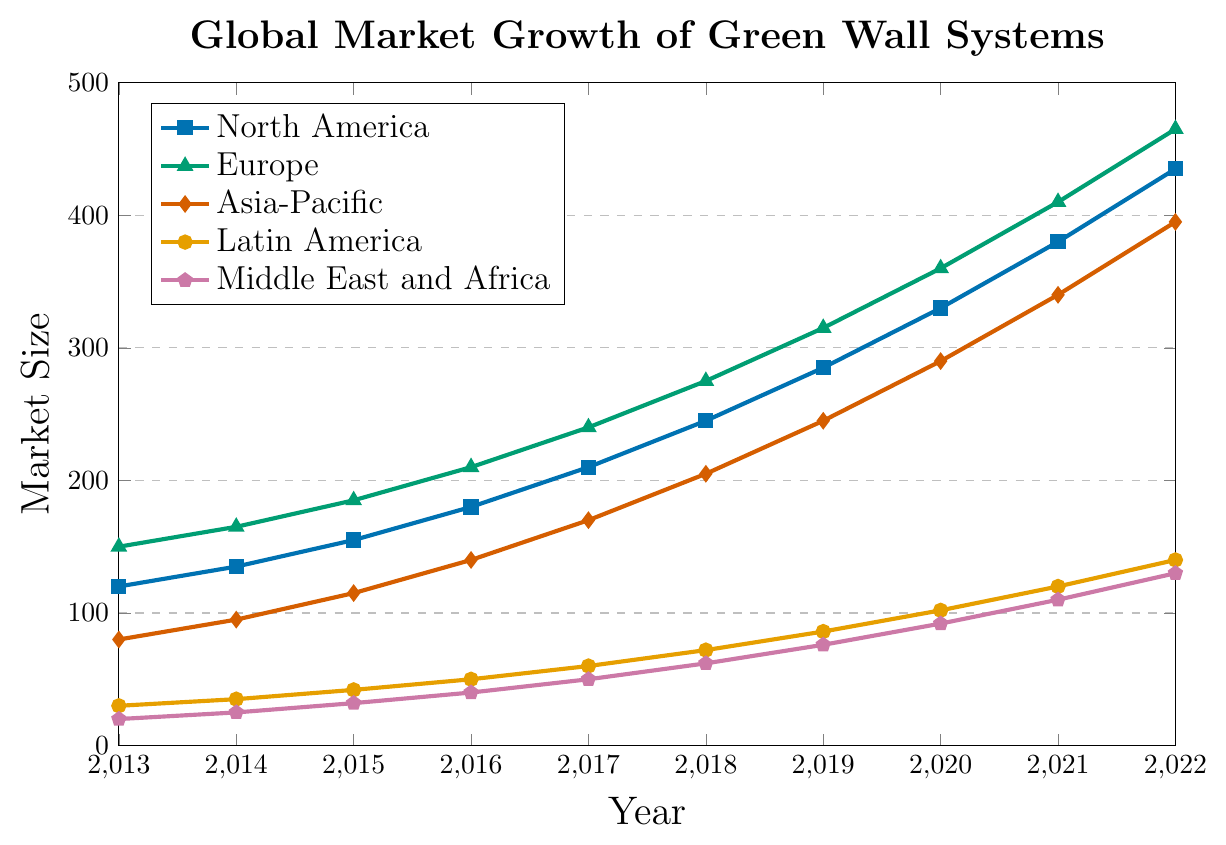What's the overall trend for the green wall system market in North America from 2013 to 2022? The market size in North America shows a consistent upward trend, increasing every year from 120 in 2013 to 435 in 2022.
Answer: Consistent upward trend In which year did Europe surpass 300 in market size? By closely observing the line representing Europe, we see that the market size surpasses 300 in 2019.
Answer: 2019 Which region had the smallest market size in 2015? By observing the relative positioning of the lines in 2015, the region with the lowest value is the Middle East and Africa, with a market size of 32.
Answer: Middle East and Africa What's the difference in market size between Asia-Pacific and Latin America in 2018? The market size for Asia-Pacific in 2018 is 205, and for Latin America, it is 72. The difference is 205 - 72 = 133.
Answer: 133 Which region had the highest market size in 2020? From the plot, Europe has the highest market size in 2020 at 360, higher than North America, Asia-Pacific, Latin America, and the Middle East and Africa.
Answer: Europe How much did the market size in North America grow from 2013 to 2022? The market size in North America in 2013 was 120, and in 2022, it was 435. The growth is 435 - 120 = 315.
Answer: 315 Which region shows the most significant growth rate between 2013 and 2022? The most significant growth can be determined by the steepest slope. Europe shows a significant increase from 150 in 2013 to 465 in 2022, with a growth of 315.
Answer: Europe Calculate the average market size for Latin America from 2013 to 2022. Sum the values for Latin America from 2013 to 2022 (30 + 35 + 42 + 50 + 60 + 72 + 86 + 102 + 120 + 140) = 737, and divide by the number of years (10). So, the average is 737/10 = 73.7.
Answer: 73.7 What is the total market size for all regions in 2017? Add the market sizes for each region in 2017: 210 (North America) + 240 (Europe) + 170 (Asia-Pacific) + 60 (Latin America) + 50 (Middle East and Africa) = 730.
Answer: 730 Which region has the most gradual increase in market size over the past decade? The most gradual increase is observed by comparing the slopes of the lines over time. The Middle East and Africa show a gradual increase from 20 in 2013 to 130 in 2022, indicating the most gradual increase.
Answer: Middle East and Africa 